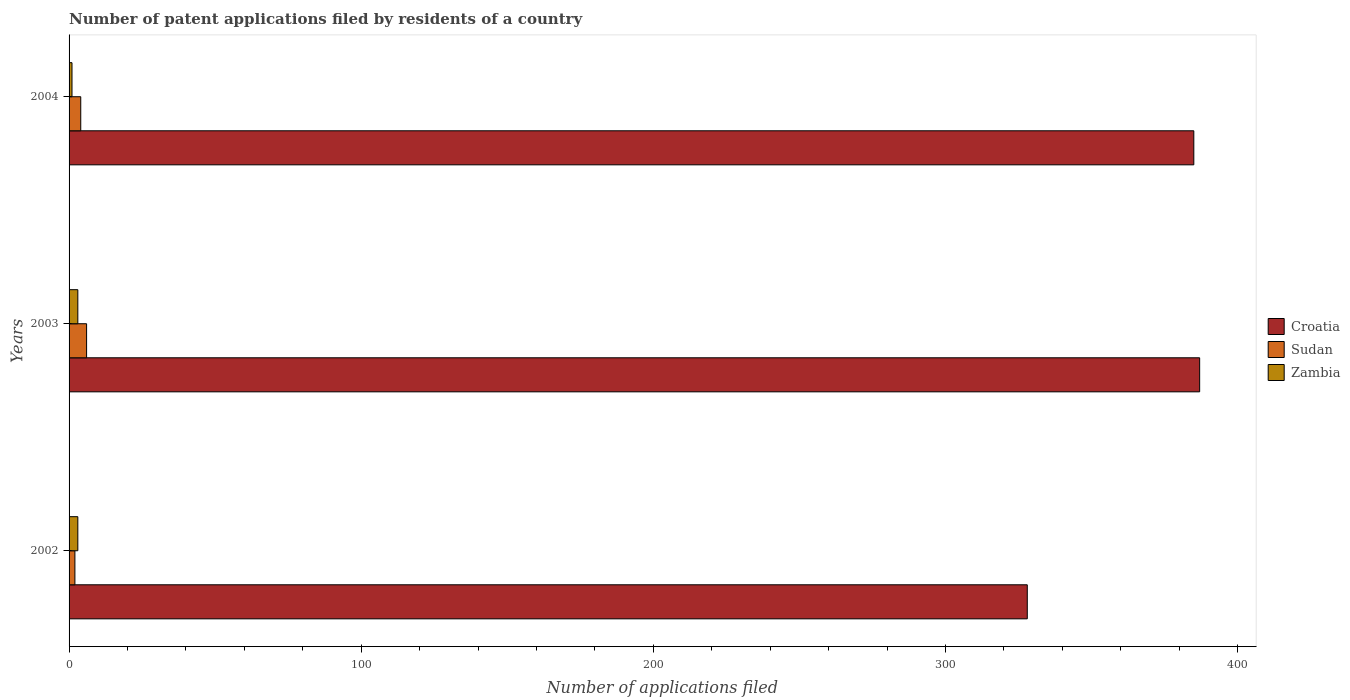How many different coloured bars are there?
Provide a succinct answer. 3. Are the number of bars on each tick of the Y-axis equal?
Offer a terse response. Yes. How many bars are there on the 2nd tick from the top?
Make the answer very short. 3. What is the label of the 2nd group of bars from the top?
Give a very brief answer. 2003. What is the number of applications filed in Sudan in 2004?
Your answer should be very brief. 4. In which year was the number of applications filed in Croatia maximum?
Offer a very short reply. 2003. In which year was the number of applications filed in Zambia minimum?
Provide a short and direct response. 2004. What is the total number of applications filed in Zambia in the graph?
Provide a succinct answer. 7. What is the difference between the number of applications filed in Zambia in 2004 and the number of applications filed in Croatia in 2002?
Offer a terse response. -327. In the year 2003, what is the difference between the number of applications filed in Zambia and number of applications filed in Croatia?
Offer a terse response. -384. Is the difference between the number of applications filed in Zambia in 2003 and 2004 greater than the difference between the number of applications filed in Croatia in 2003 and 2004?
Your answer should be very brief. No. In how many years, is the number of applications filed in Croatia greater than the average number of applications filed in Croatia taken over all years?
Offer a very short reply. 2. What does the 3rd bar from the top in 2004 represents?
Your answer should be compact. Croatia. What does the 3rd bar from the bottom in 2003 represents?
Provide a succinct answer. Zambia. Is it the case that in every year, the sum of the number of applications filed in Croatia and number of applications filed in Sudan is greater than the number of applications filed in Zambia?
Keep it short and to the point. Yes. Are all the bars in the graph horizontal?
Your answer should be compact. Yes. How many years are there in the graph?
Offer a very short reply. 3. Does the graph contain any zero values?
Your answer should be compact. No. Does the graph contain grids?
Give a very brief answer. No. Where does the legend appear in the graph?
Your answer should be compact. Center right. How many legend labels are there?
Provide a short and direct response. 3. What is the title of the graph?
Make the answer very short. Number of patent applications filed by residents of a country. Does "Bahamas" appear as one of the legend labels in the graph?
Your answer should be compact. No. What is the label or title of the X-axis?
Give a very brief answer. Number of applications filed. What is the Number of applications filed of Croatia in 2002?
Make the answer very short. 328. What is the Number of applications filed in Zambia in 2002?
Make the answer very short. 3. What is the Number of applications filed of Croatia in 2003?
Give a very brief answer. 387. What is the Number of applications filed in Sudan in 2003?
Keep it short and to the point. 6. What is the Number of applications filed of Croatia in 2004?
Offer a very short reply. 385. What is the Number of applications filed of Sudan in 2004?
Your answer should be very brief. 4. Across all years, what is the maximum Number of applications filed of Croatia?
Offer a terse response. 387. Across all years, what is the minimum Number of applications filed of Croatia?
Your response must be concise. 328. Across all years, what is the minimum Number of applications filed in Zambia?
Make the answer very short. 1. What is the total Number of applications filed in Croatia in the graph?
Provide a short and direct response. 1100. What is the difference between the Number of applications filed of Croatia in 2002 and that in 2003?
Offer a very short reply. -59. What is the difference between the Number of applications filed in Sudan in 2002 and that in 2003?
Your response must be concise. -4. What is the difference between the Number of applications filed of Zambia in 2002 and that in 2003?
Give a very brief answer. 0. What is the difference between the Number of applications filed in Croatia in 2002 and that in 2004?
Provide a short and direct response. -57. What is the difference between the Number of applications filed in Sudan in 2002 and that in 2004?
Offer a very short reply. -2. What is the difference between the Number of applications filed of Croatia in 2002 and the Number of applications filed of Sudan in 2003?
Provide a succinct answer. 322. What is the difference between the Number of applications filed of Croatia in 2002 and the Number of applications filed of Zambia in 2003?
Your response must be concise. 325. What is the difference between the Number of applications filed in Sudan in 2002 and the Number of applications filed in Zambia in 2003?
Your answer should be compact. -1. What is the difference between the Number of applications filed in Croatia in 2002 and the Number of applications filed in Sudan in 2004?
Offer a terse response. 324. What is the difference between the Number of applications filed of Croatia in 2002 and the Number of applications filed of Zambia in 2004?
Make the answer very short. 327. What is the difference between the Number of applications filed in Sudan in 2002 and the Number of applications filed in Zambia in 2004?
Offer a terse response. 1. What is the difference between the Number of applications filed of Croatia in 2003 and the Number of applications filed of Sudan in 2004?
Ensure brevity in your answer.  383. What is the difference between the Number of applications filed of Croatia in 2003 and the Number of applications filed of Zambia in 2004?
Your response must be concise. 386. What is the difference between the Number of applications filed in Sudan in 2003 and the Number of applications filed in Zambia in 2004?
Ensure brevity in your answer.  5. What is the average Number of applications filed in Croatia per year?
Make the answer very short. 366.67. What is the average Number of applications filed of Zambia per year?
Provide a succinct answer. 2.33. In the year 2002, what is the difference between the Number of applications filed of Croatia and Number of applications filed of Sudan?
Your answer should be compact. 326. In the year 2002, what is the difference between the Number of applications filed in Croatia and Number of applications filed in Zambia?
Your response must be concise. 325. In the year 2003, what is the difference between the Number of applications filed in Croatia and Number of applications filed in Sudan?
Ensure brevity in your answer.  381. In the year 2003, what is the difference between the Number of applications filed of Croatia and Number of applications filed of Zambia?
Your response must be concise. 384. In the year 2004, what is the difference between the Number of applications filed of Croatia and Number of applications filed of Sudan?
Your answer should be very brief. 381. In the year 2004, what is the difference between the Number of applications filed in Croatia and Number of applications filed in Zambia?
Offer a terse response. 384. In the year 2004, what is the difference between the Number of applications filed in Sudan and Number of applications filed in Zambia?
Keep it short and to the point. 3. What is the ratio of the Number of applications filed of Croatia in 2002 to that in 2003?
Provide a short and direct response. 0.85. What is the ratio of the Number of applications filed in Zambia in 2002 to that in 2003?
Provide a short and direct response. 1. What is the ratio of the Number of applications filed of Croatia in 2002 to that in 2004?
Make the answer very short. 0.85. What is the ratio of the Number of applications filed of Sudan in 2002 to that in 2004?
Make the answer very short. 0.5. What is the difference between the highest and the second highest Number of applications filed of Sudan?
Offer a very short reply. 2. What is the difference between the highest and the second highest Number of applications filed of Zambia?
Offer a very short reply. 0. What is the difference between the highest and the lowest Number of applications filed of Croatia?
Ensure brevity in your answer.  59. What is the difference between the highest and the lowest Number of applications filed in Zambia?
Your response must be concise. 2. 